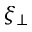Convert formula to latex. <formula><loc_0><loc_0><loc_500><loc_500>\xi _ { \perp }</formula> 